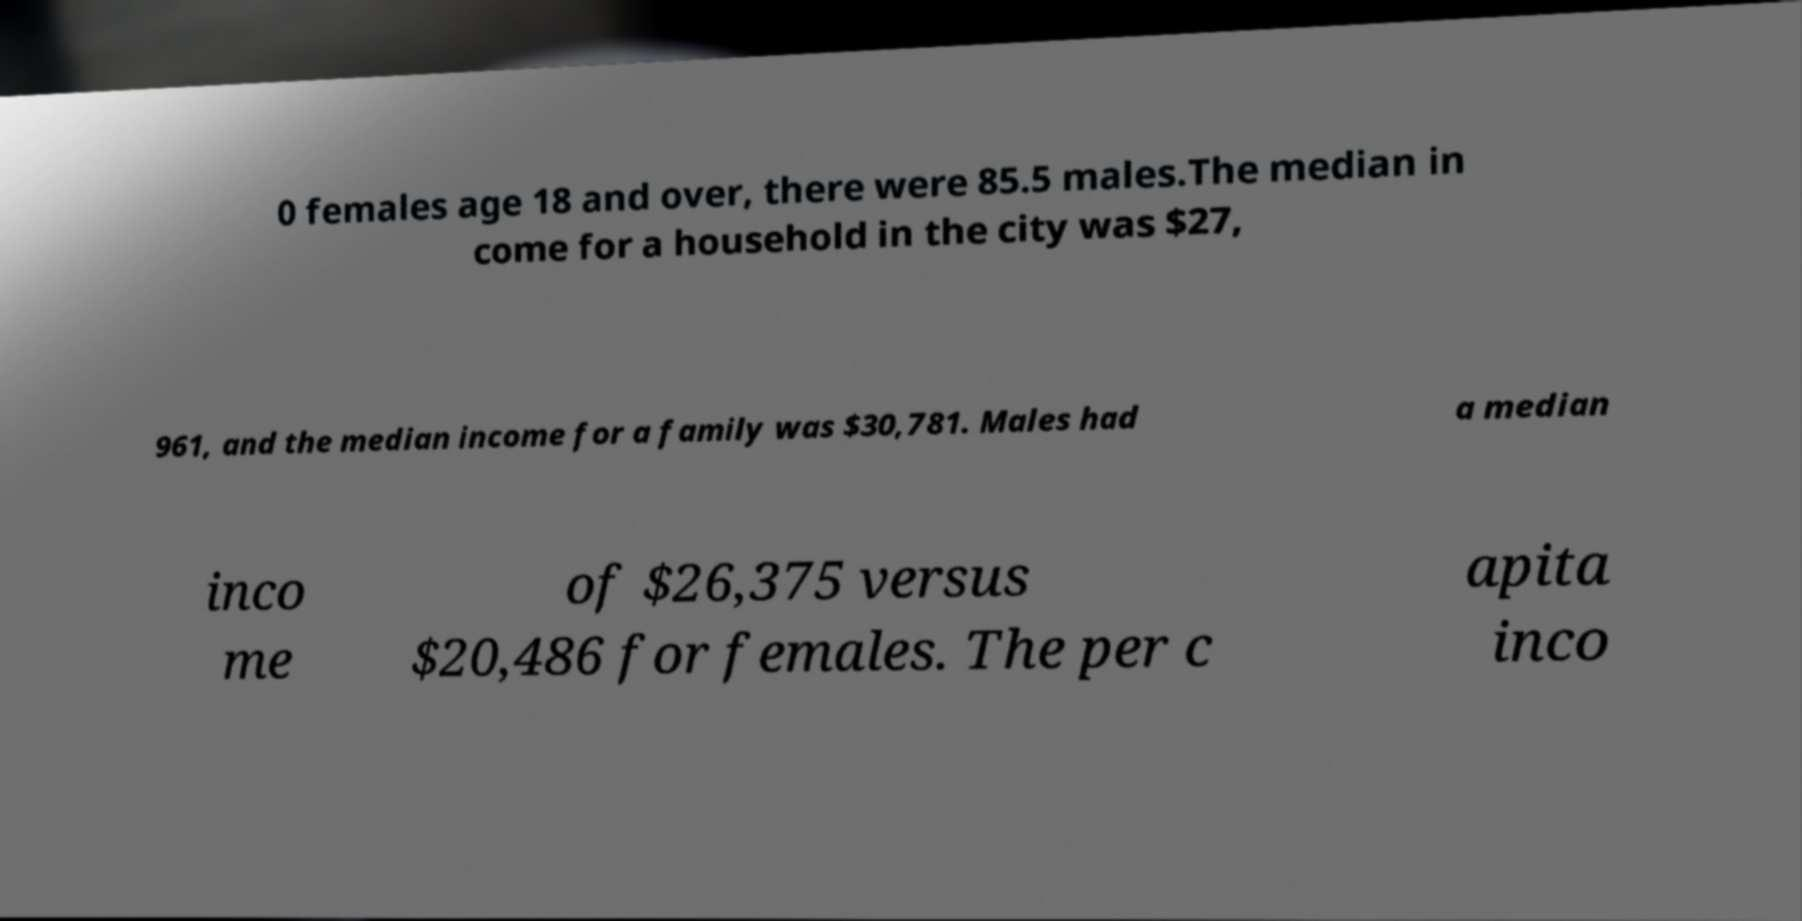I need the written content from this picture converted into text. Can you do that? 0 females age 18 and over, there were 85.5 males.The median in come for a household in the city was $27, 961, and the median income for a family was $30,781. Males had a median inco me of $26,375 versus $20,486 for females. The per c apita inco 